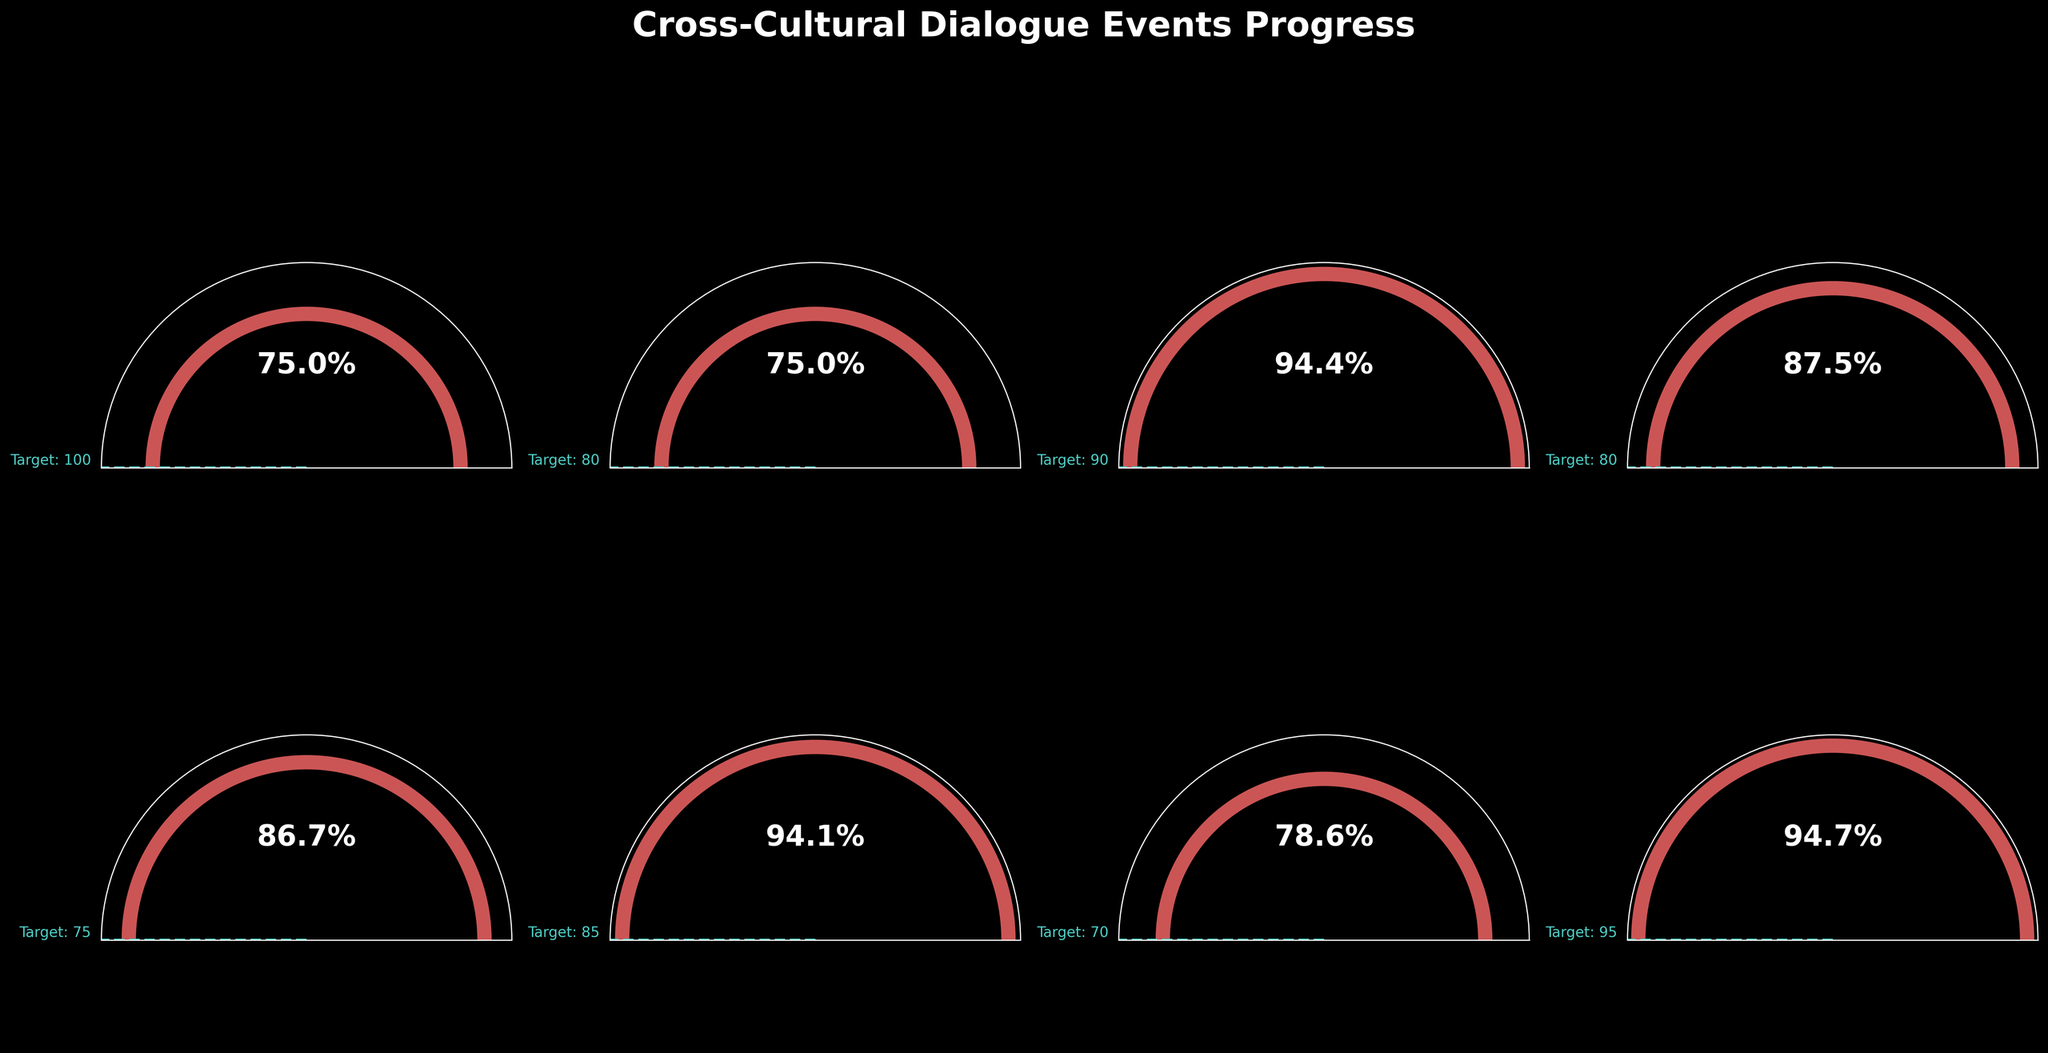What is the title of the figure? The title can be found at the top of the figure.
Answer: Cross-Cultural Dialogue Events Progress Which event has the highest percentage completion? Look at the percentage values inside the arcs, and identify the event with the highest percentage.
Answer: Intercultural Communication Workshop What is the percentage completion for the Global Perspectives Debate event? Check the value inside the arc for the Global Perspectives Debate event.
Answer: 87.5% Which events exceeded 80% of their target goals? Identify events with percentage completion values above 80%, by examining each arc.
Answer: Diversity Awareness Workshop, Cross-Cultural Conflict Resolution Seminar, Intercultural Communication Workshop How many events have a target goal of 100? Count the number of arcs that show a target value line at 100.
Answer: 1 Between the International Student Mixer and the World Religion Roundtable, which event has a higher percentage completion? Compare the percentage values inside the arcs for both events.
Answer: International Student Mixer What is the average percentage completion across all events? Calculate the percentage completion for each event, sum them up, and divide by the number of events. Formula: (75/100 + 60/80 + 85/90 + 70/80 + 65/75 + 80/85 + 55/70 + 90/95) / 8
Answer: 80.3% How much percentage more does the Monthly Cultural Exchange Forum need to reach its target? Subtract the percentage completion from 100 for the Monthly Cultural Exchange Forum event.
Answer: 25% Which event is closest to reaching its target goal? Identify the event whose percentage value is closest to 100%.
Answer: Intercultural Communication Workshop 